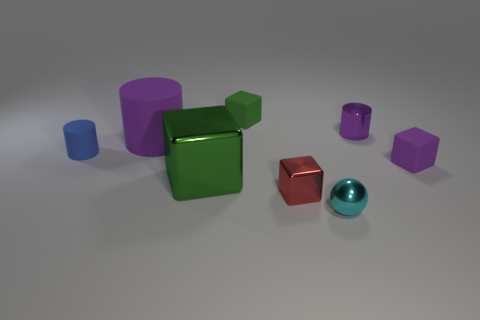Aside from their colors, are there any differences in the finish or texture of these objects? All objects have a matte finish, and no distinguishable texture differences are observable from this image. They all share a uniform, smooth appearance without shininess or gloss. Is there a color that is most dominant among the objects? Green appears to be the most dominant color in this assortment, as the largest object displayed is a green cube. 